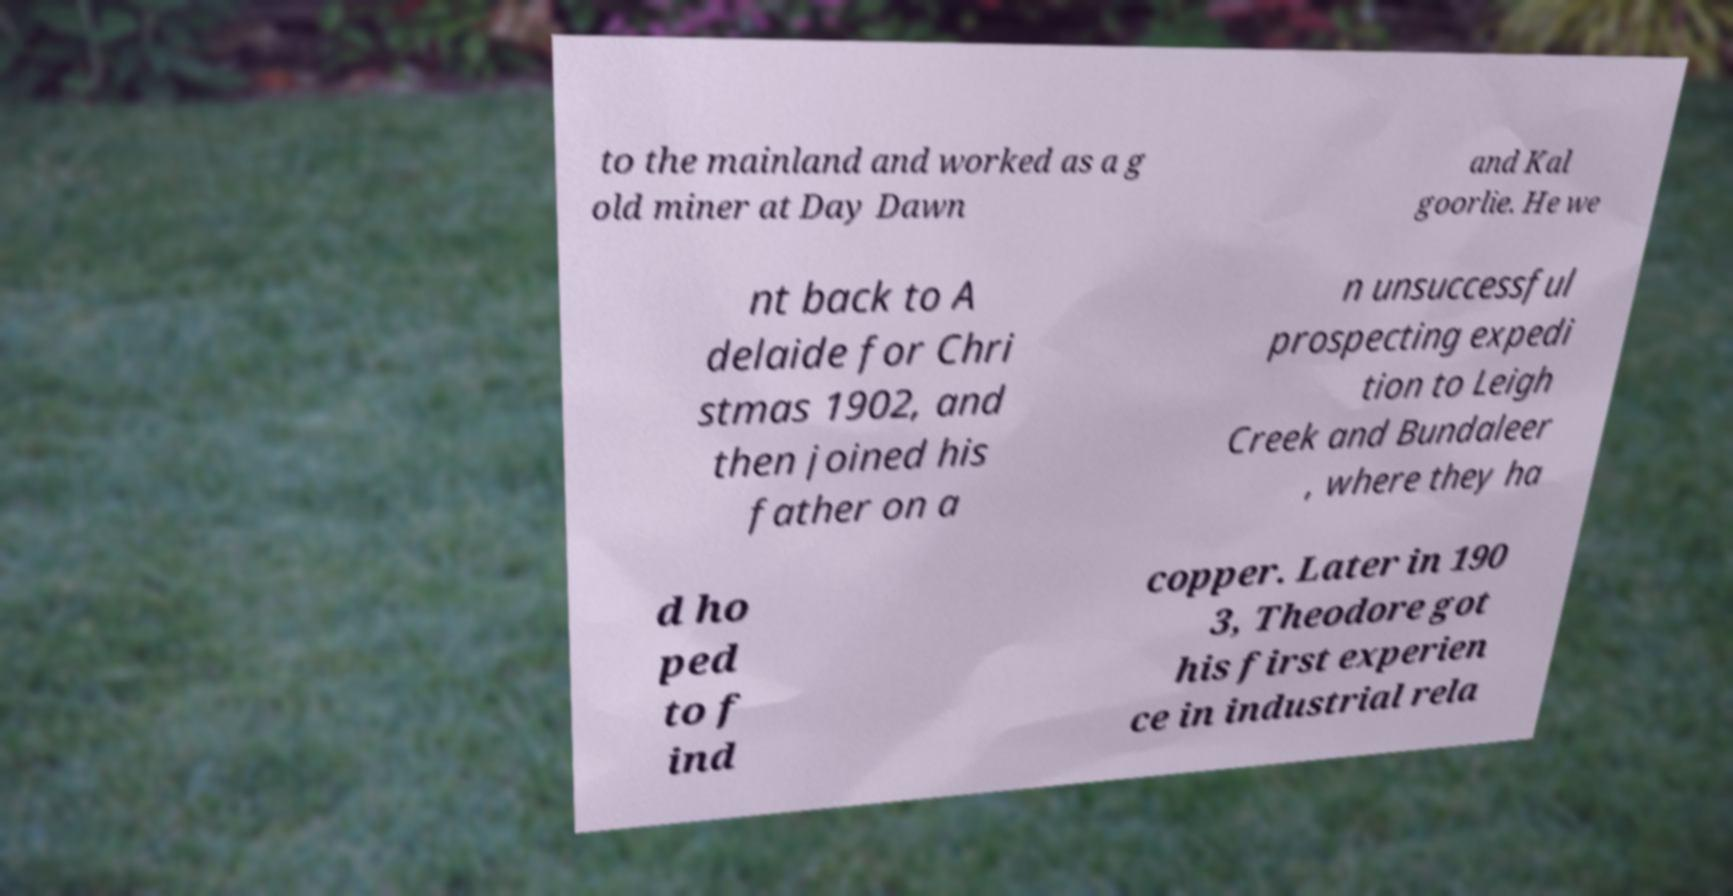Can you read and provide the text displayed in the image?This photo seems to have some interesting text. Can you extract and type it out for me? to the mainland and worked as a g old miner at Day Dawn and Kal goorlie. He we nt back to A delaide for Chri stmas 1902, and then joined his father on a n unsuccessful prospecting expedi tion to Leigh Creek and Bundaleer , where they ha d ho ped to f ind copper. Later in 190 3, Theodore got his first experien ce in industrial rela 